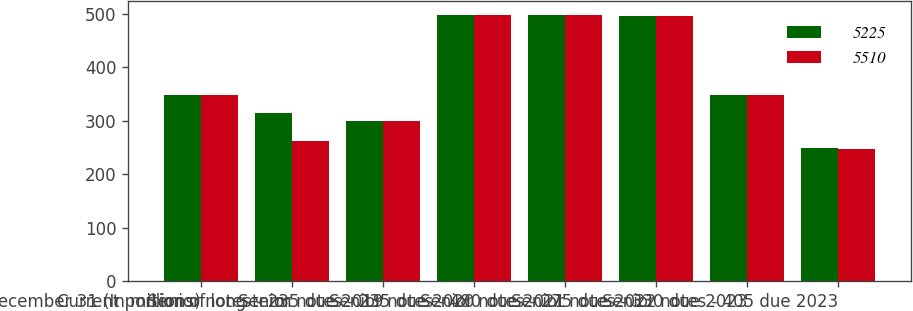<chart> <loc_0><loc_0><loc_500><loc_500><stacked_bar_chart><ecel><fcel>December 31 (In millions)<fcel>Current portion of long-term<fcel>Senior notes - 235 due 2019<fcel>Senior notes - 235 due 2020<fcel>Senior notes - 480 due 2021<fcel>Senior notes - 275 due 2022<fcel>Senior notes - 330 due 2023<fcel>Senior notes - 405 due 2023<nl><fcel>5225<fcel>348<fcel>314<fcel>300<fcel>499<fcel>499<fcel>497<fcel>348<fcel>249<nl><fcel>5510<fcel>348<fcel>262<fcel>299<fcel>498<fcel>498<fcel>496<fcel>348<fcel>248<nl></chart> 